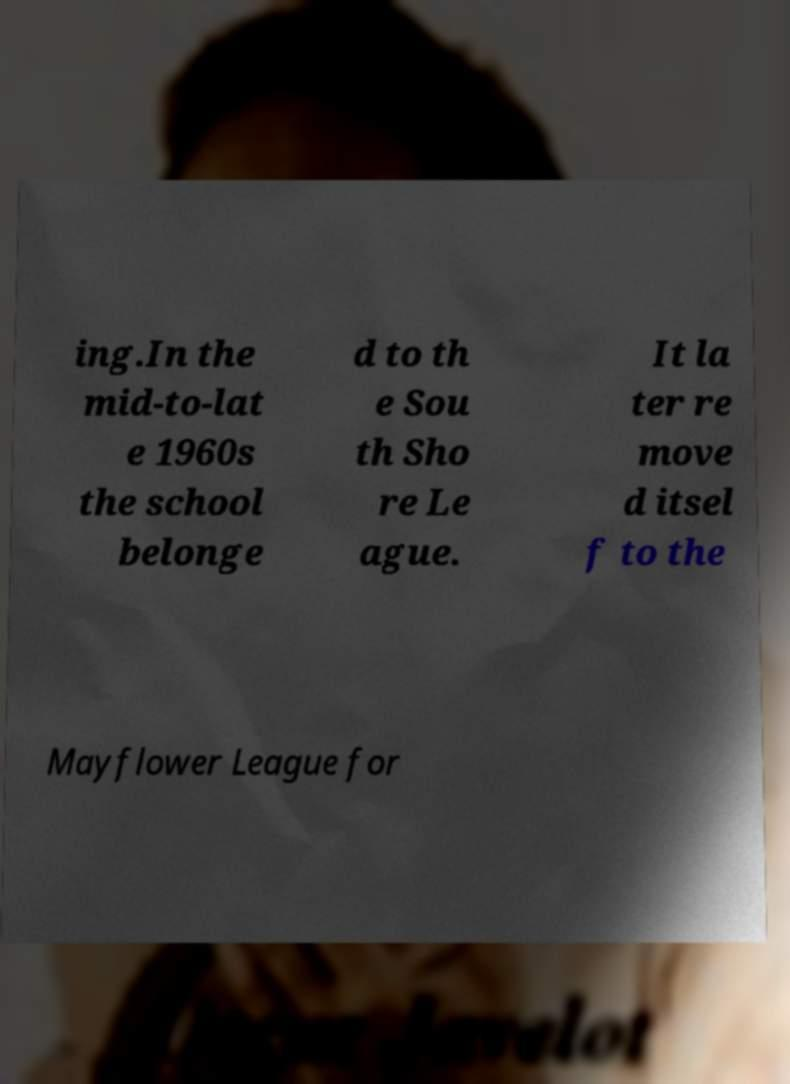Please read and relay the text visible in this image. What does it say? ing.In the mid-to-lat e 1960s the school belonge d to th e Sou th Sho re Le ague. It la ter re move d itsel f to the Mayflower League for 